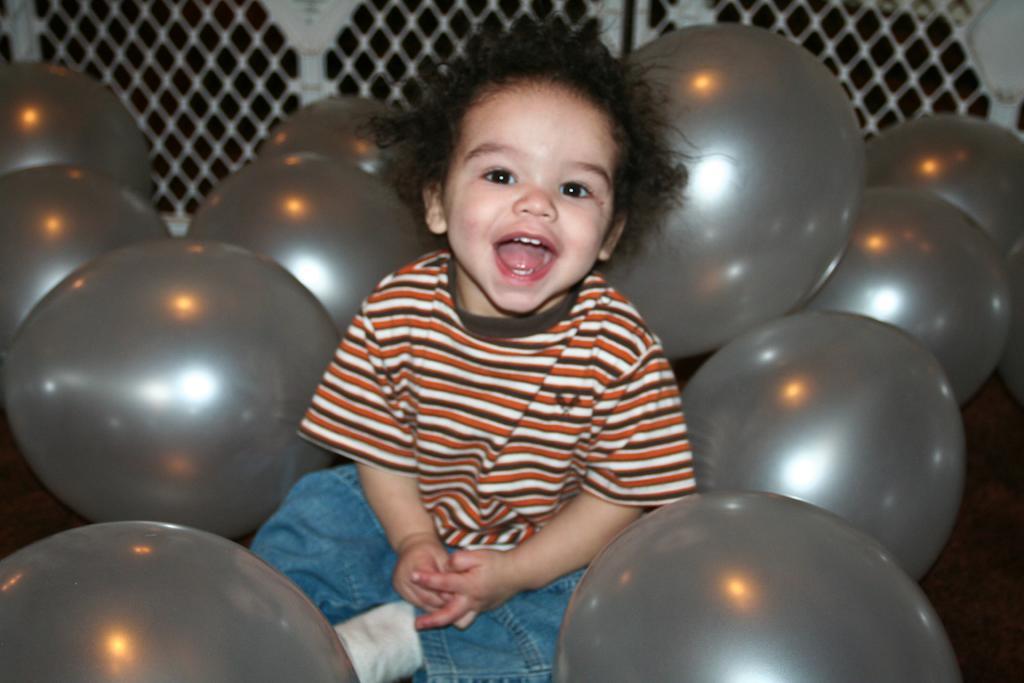How would you summarize this image in a sentence or two? In this picture this is a boy who is wearing t-shirt, short and socks. he is sitting near to the grey color balloons. On the top we can see fencing. 